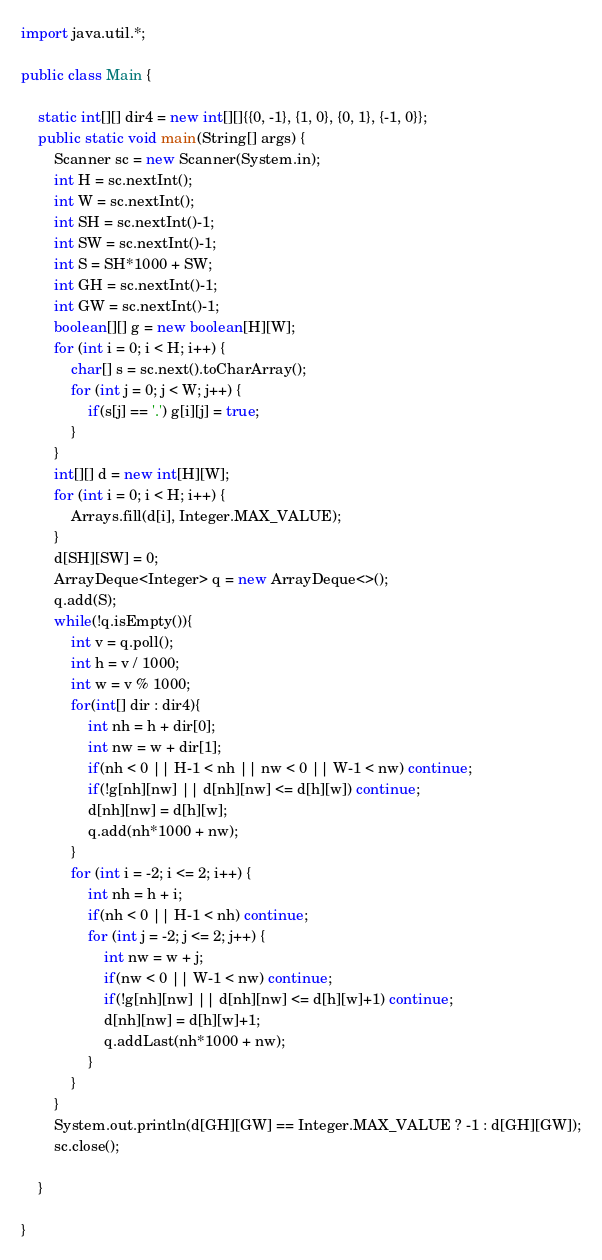<code> <loc_0><loc_0><loc_500><loc_500><_Java_>import java.util.*;

public class Main {

    static int[][] dir4 = new int[][]{{0, -1}, {1, 0}, {0, 1}, {-1, 0}};
    public static void main(String[] args) {
        Scanner sc = new Scanner(System.in);
        int H = sc.nextInt();
        int W = sc.nextInt();
        int SH = sc.nextInt()-1;
        int SW = sc.nextInt()-1;
        int S = SH*1000 + SW;
        int GH = sc.nextInt()-1;
        int GW = sc.nextInt()-1;
        boolean[][] g = new boolean[H][W];
        for (int i = 0; i < H; i++) {
            char[] s = sc.next().toCharArray();
            for (int j = 0; j < W; j++) {
                if(s[j] == '.') g[i][j] = true;
            }
        }
        int[][] d = new int[H][W];
        for (int i = 0; i < H; i++) {
            Arrays.fill(d[i], Integer.MAX_VALUE);
        }
        d[SH][SW] = 0;
        ArrayDeque<Integer> q = new ArrayDeque<>();
        q.add(S);
        while(!q.isEmpty()){
            int v = q.poll();
            int h = v / 1000;
            int w = v % 1000;
            for(int[] dir : dir4){
                int nh = h + dir[0];
                int nw = w + dir[1];
                if(nh < 0 || H-1 < nh || nw < 0 || W-1 < nw) continue;
                if(!g[nh][nw] || d[nh][nw] <= d[h][w]) continue;
                d[nh][nw] = d[h][w];
                q.add(nh*1000 + nw);
            }
            for (int i = -2; i <= 2; i++) {
                int nh = h + i;
                if(nh < 0 || H-1 < nh) continue;
                for (int j = -2; j <= 2; j++) {
                    int nw = w + j;
                    if(nw < 0 || W-1 < nw) continue;
                    if(!g[nh][nw] || d[nh][nw] <= d[h][w]+1) continue;
                    d[nh][nw] = d[h][w]+1;
                    q.addLast(nh*1000 + nw);
                }
            }
        }
        System.out.println(d[GH][GW] == Integer.MAX_VALUE ? -1 : d[GH][GW]);
        sc.close();

    }

}
</code> 